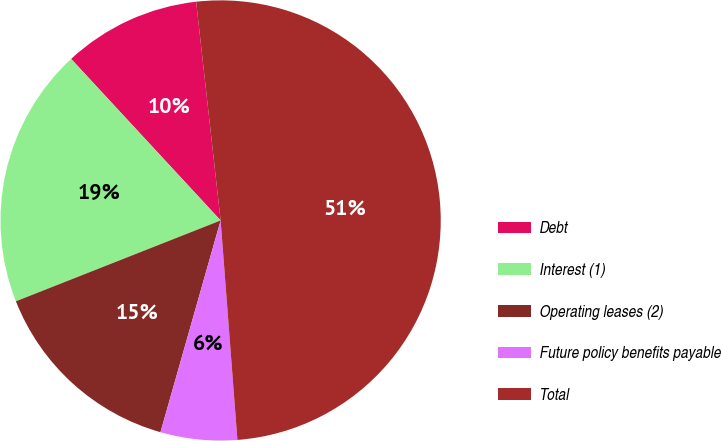<chart> <loc_0><loc_0><loc_500><loc_500><pie_chart><fcel>Debt<fcel>Interest (1)<fcel>Operating leases (2)<fcel>Future policy benefits payable<fcel>Total<nl><fcel>10.11%<fcel>19.1%<fcel>14.61%<fcel>5.62%<fcel>50.56%<nl></chart> 